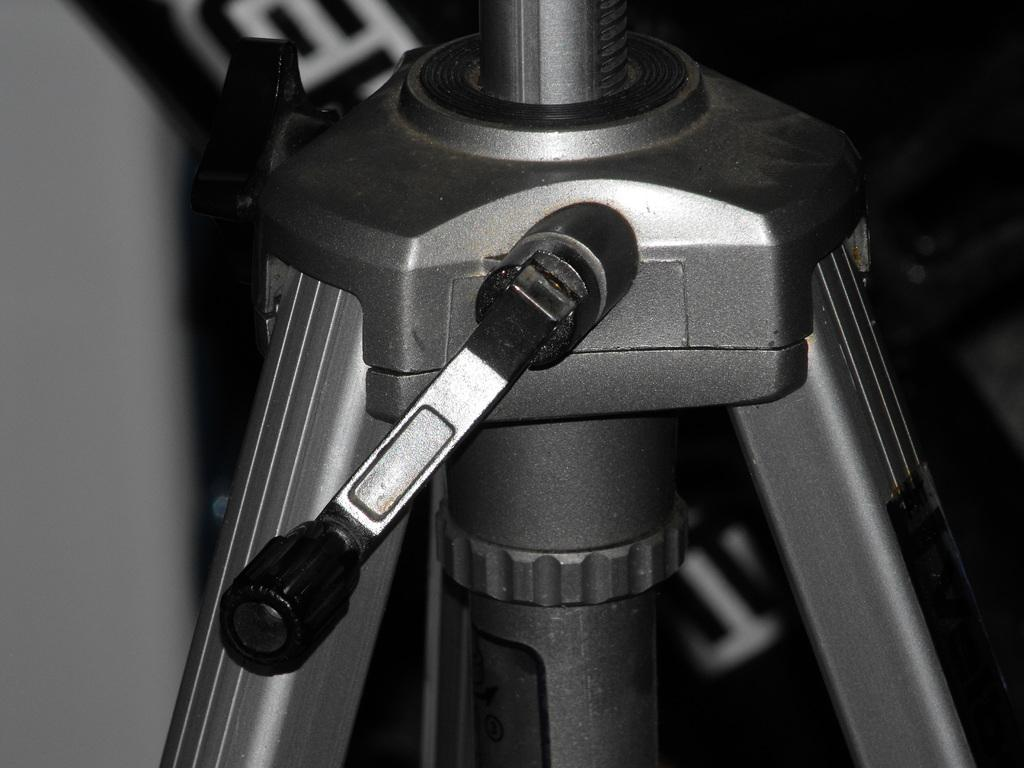What is the main object in the image? There is a tripod stand in the image. What feature does the tripod stand have? The tripod stand stand has a positioning handle. What can be observed about the background of the image? The background of the image is dark. What is the user's desire for the morning in the image? There is no mention of a user or their desires in the image; it only features a tripod stand with a positioning handle and a dark background. 